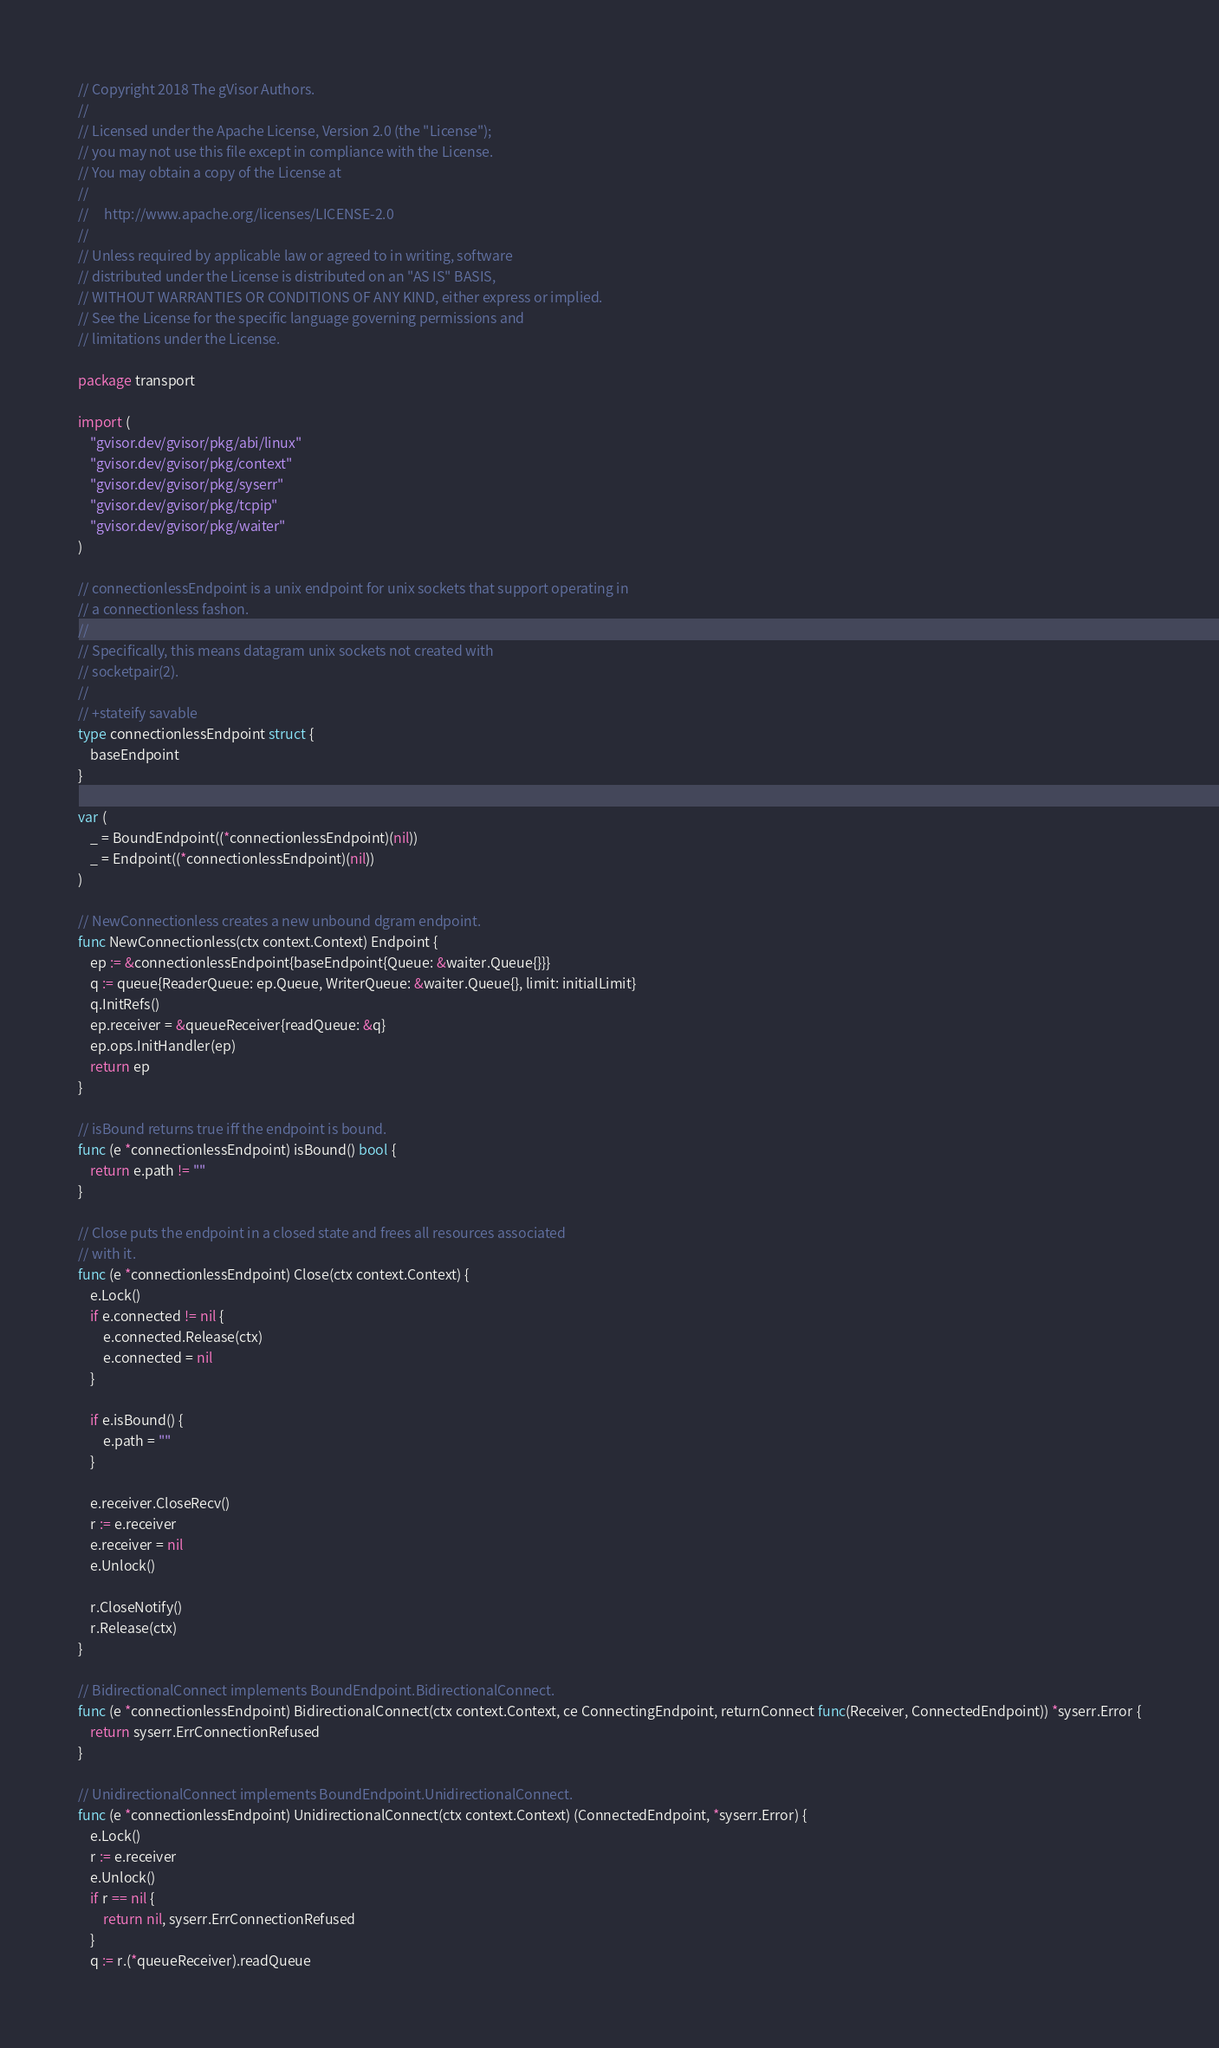<code> <loc_0><loc_0><loc_500><loc_500><_Go_>// Copyright 2018 The gVisor Authors.
//
// Licensed under the Apache License, Version 2.0 (the "License");
// you may not use this file except in compliance with the License.
// You may obtain a copy of the License at
//
//     http://www.apache.org/licenses/LICENSE-2.0
//
// Unless required by applicable law or agreed to in writing, software
// distributed under the License is distributed on an "AS IS" BASIS,
// WITHOUT WARRANTIES OR CONDITIONS OF ANY KIND, either express or implied.
// See the License for the specific language governing permissions and
// limitations under the License.

package transport

import (
	"gvisor.dev/gvisor/pkg/abi/linux"
	"gvisor.dev/gvisor/pkg/context"
	"gvisor.dev/gvisor/pkg/syserr"
	"gvisor.dev/gvisor/pkg/tcpip"
	"gvisor.dev/gvisor/pkg/waiter"
)

// connectionlessEndpoint is a unix endpoint for unix sockets that support operating in
// a connectionless fashon.
//
// Specifically, this means datagram unix sockets not created with
// socketpair(2).
//
// +stateify savable
type connectionlessEndpoint struct {
	baseEndpoint
}

var (
	_ = BoundEndpoint((*connectionlessEndpoint)(nil))
	_ = Endpoint((*connectionlessEndpoint)(nil))
)

// NewConnectionless creates a new unbound dgram endpoint.
func NewConnectionless(ctx context.Context) Endpoint {
	ep := &connectionlessEndpoint{baseEndpoint{Queue: &waiter.Queue{}}}
	q := queue{ReaderQueue: ep.Queue, WriterQueue: &waiter.Queue{}, limit: initialLimit}
	q.InitRefs()
	ep.receiver = &queueReceiver{readQueue: &q}
	ep.ops.InitHandler(ep)
	return ep
}

// isBound returns true iff the endpoint is bound.
func (e *connectionlessEndpoint) isBound() bool {
	return e.path != ""
}

// Close puts the endpoint in a closed state and frees all resources associated
// with it.
func (e *connectionlessEndpoint) Close(ctx context.Context) {
	e.Lock()
	if e.connected != nil {
		e.connected.Release(ctx)
		e.connected = nil
	}

	if e.isBound() {
		e.path = ""
	}

	e.receiver.CloseRecv()
	r := e.receiver
	e.receiver = nil
	e.Unlock()

	r.CloseNotify()
	r.Release(ctx)
}

// BidirectionalConnect implements BoundEndpoint.BidirectionalConnect.
func (e *connectionlessEndpoint) BidirectionalConnect(ctx context.Context, ce ConnectingEndpoint, returnConnect func(Receiver, ConnectedEndpoint)) *syserr.Error {
	return syserr.ErrConnectionRefused
}

// UnidirectionalConnect implements BoundEndpoint.UnidirectionalConnect.
func (e *connectionlessEndpoint) UnidirectionalConnect(ctx context.Context) (ConnectedEndpoint, *syserr.Error) {
	e.Lock()
	r := e.receiver
	e.Unlock()
	if r == nil {
		return nil, syserr.ErrConnectionRefused
	}
	q := r.(*queueReceiver).readQueue</code> 